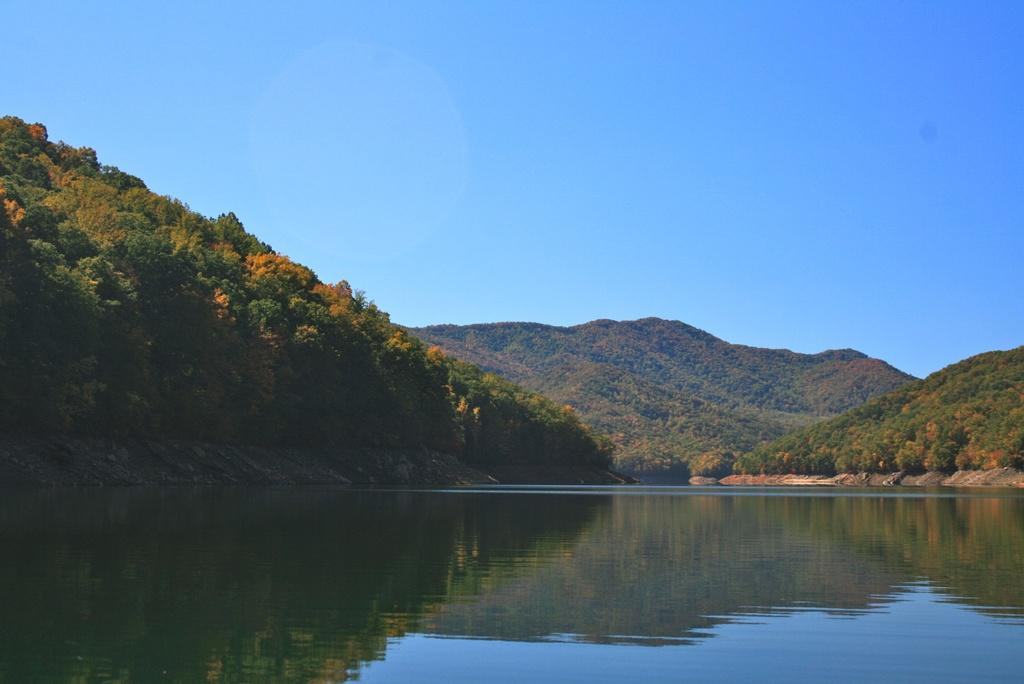What is at the bottom of the image? There is water at the bottom of the image. What can be seen in the background of the image? There are trees in the background of the image. What is visible at the top of the image? The sky is visible at the top of the image. What type of lead is being used by the dad in the image? There is no dad or lead present in the image. What type of machine is visible in the background of the image? There is no machine visible in the image; only trees are present in the background. 